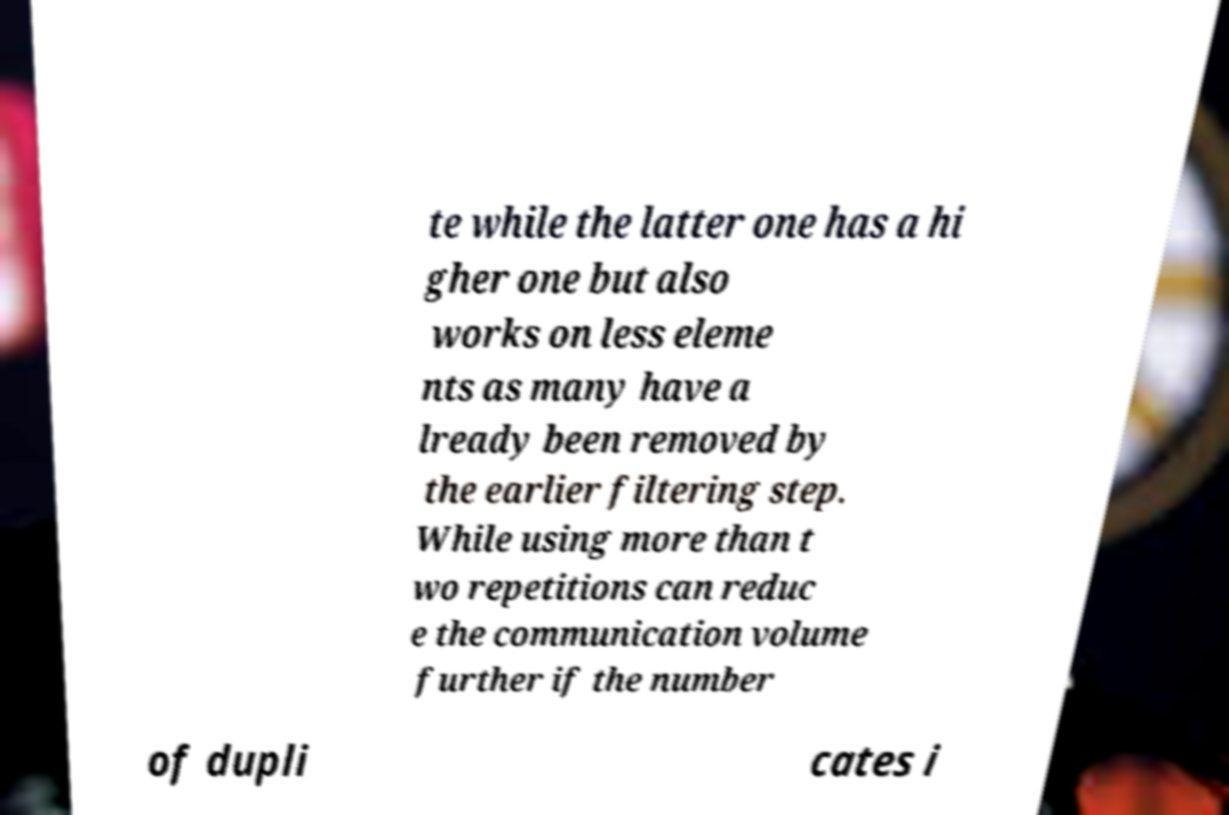Please read and relay the text visible in this image. What does it say? te while the latter one has a hi gher one but also works on less eleme nts as many have a lready been removed by the earlier filtering step. While using more than t wo repetitions can reduc e the communication volume further if the number of dupli cates i 